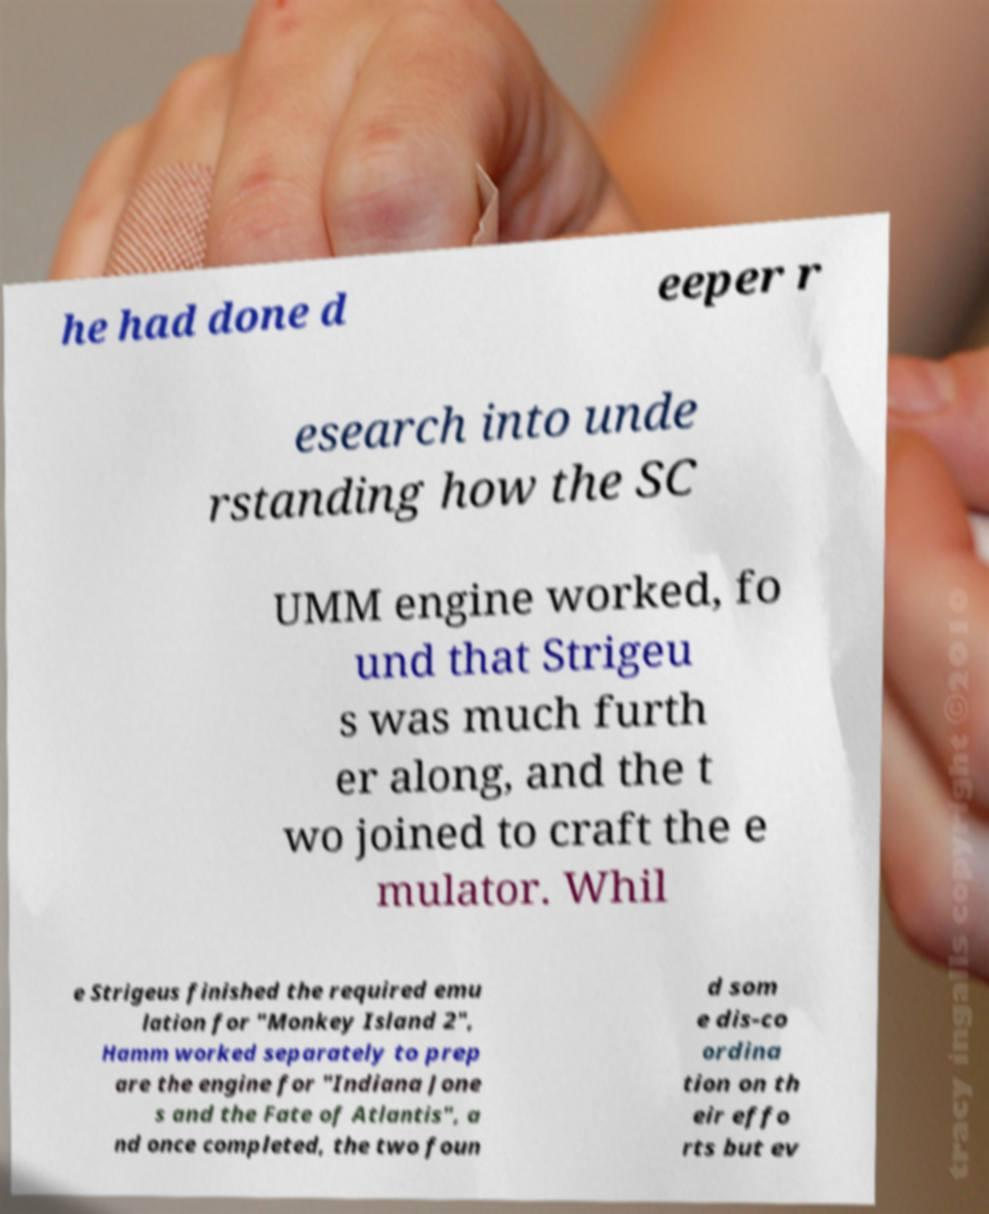Could you extract and type out the text from this image? he had done d eeper r esearch into unde rstanding how the SC UMM engine worked, fo und that Strigeu s was much furth er along, and the t wo joined to craft the e mulator. Whil e Strigeus finished the required emu lation for "Monkey Island 2", Hamm worked separately to prep are the engine for "Indiana Jone s and the Fate of Atlantis", a nd once completed, the two foun d som e dis-co ordina tion on th eir effo rts but ev 